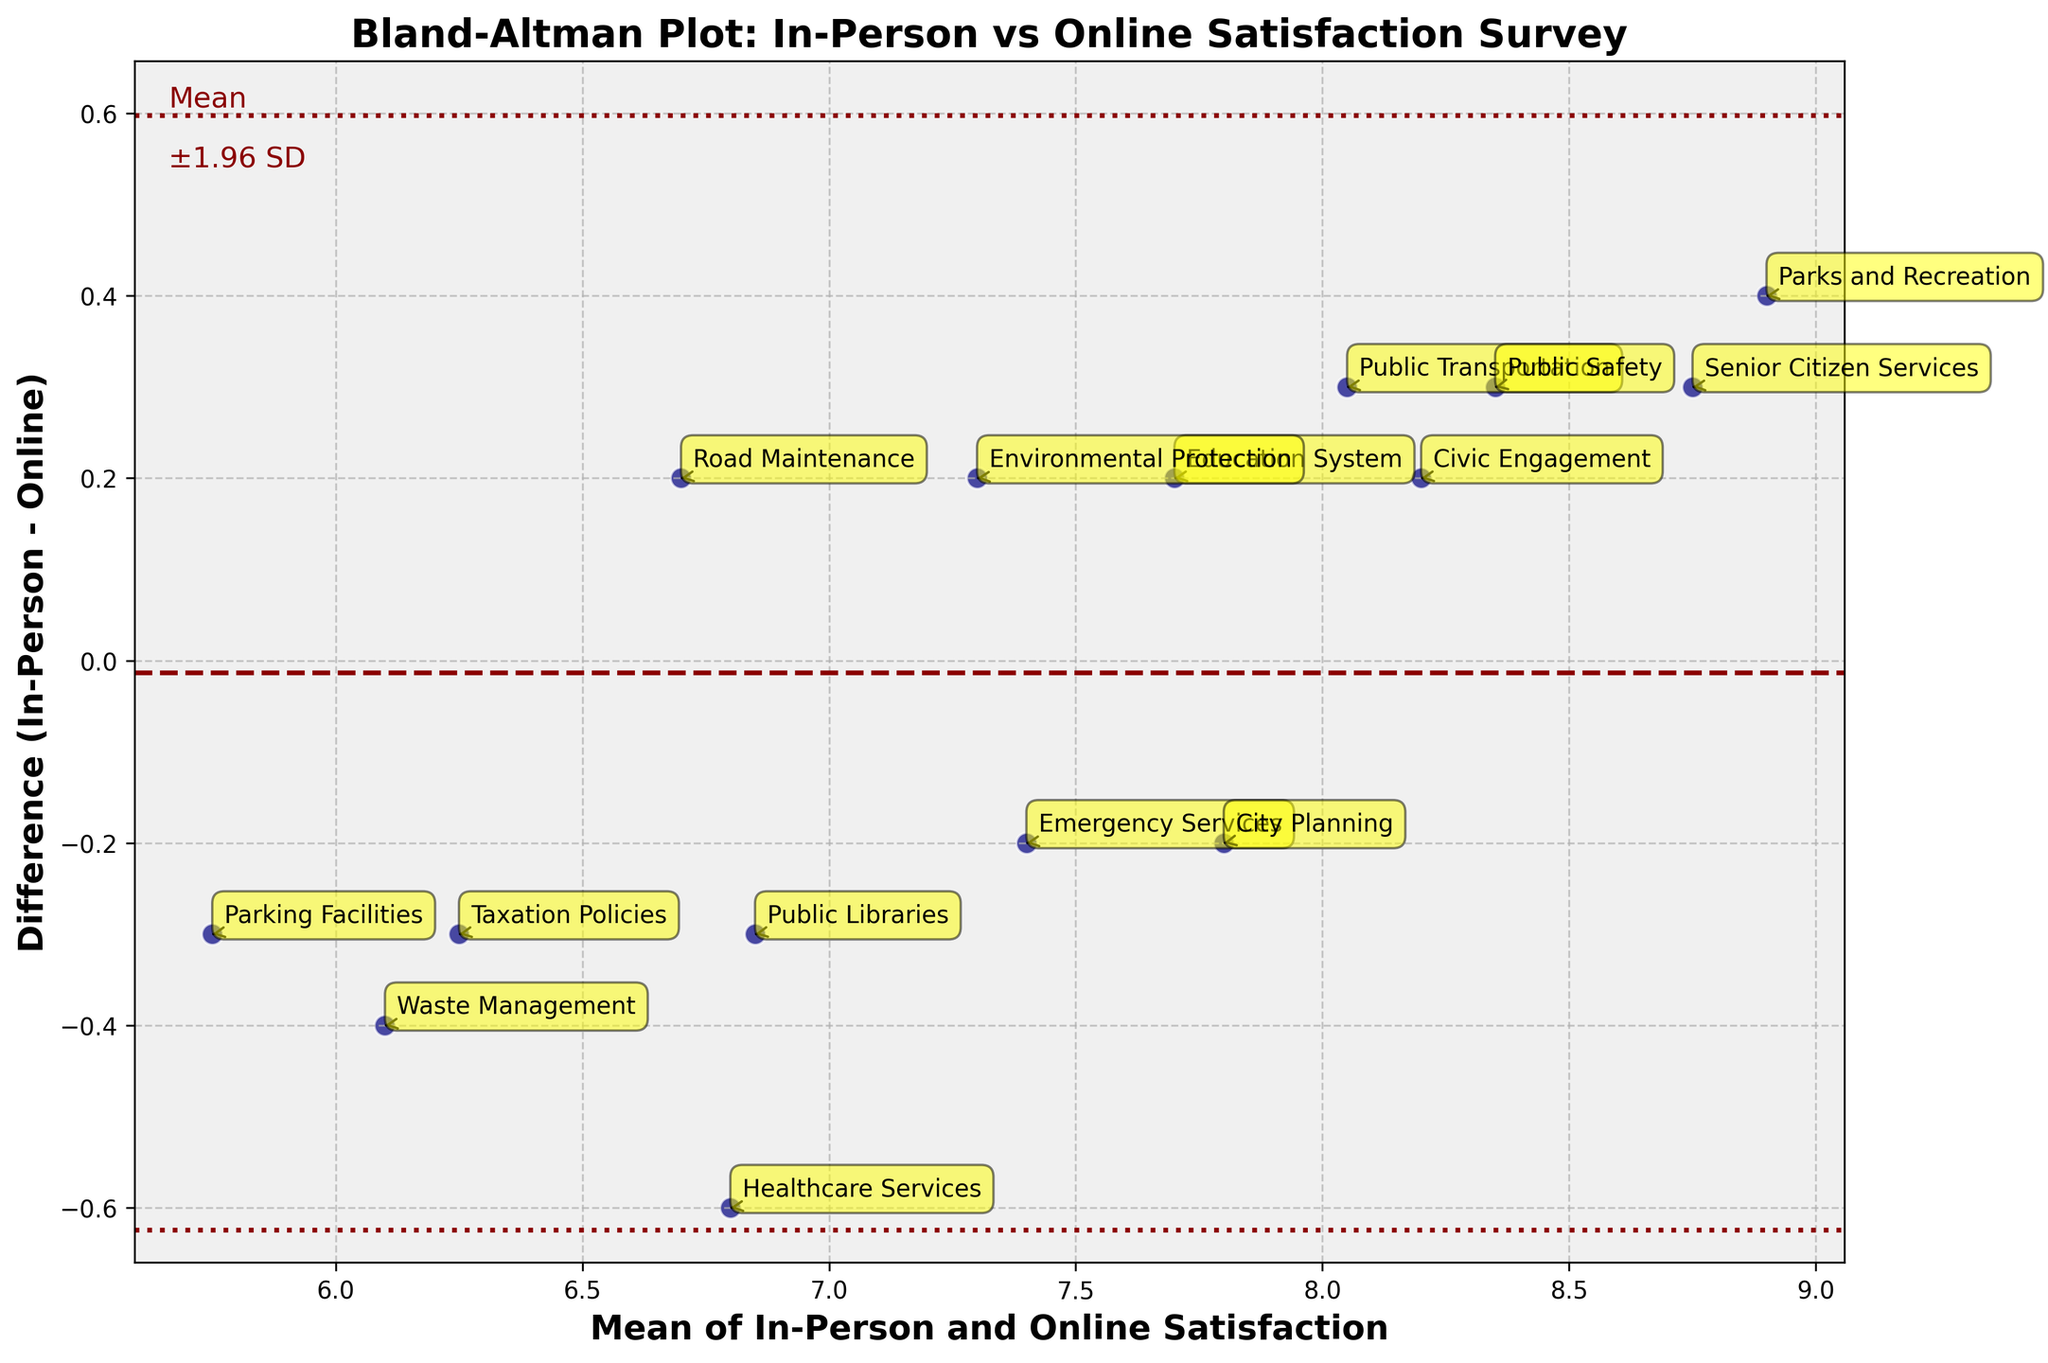How many data points are shown in the plot? To determine the number of data points, observe the number of scatter points present on the plot. Count each point representing a different category.
Answer: 15 What is the title of the plot? Identify the text at the top center of the plot, serving as a descriptor for the visualized data.
Answer: Bland-Altman Plot: In-Person vs Online Satisfaction Survey What do the lines labeled "±1.96 SD" represent? The lines marked as "±1.96 SD" refer to the limits of agreement, indicating where the differences between in-person and online satisfaction results fall within 1.96 standard deviations from the mean difference. These lines help assess the level of agreement.
Answer: Limits of agreement What is the mean difference between the in-person and online surveys? Locate the line that represents the mean difference on the plot. It’s the horizontal line positioned centrally among the data points, annotated as "Mean". Follow the position of this line on the y-axis.
Answer: Approximately 0 Which category shows the largest positive difference between in-person and online satisfaction? Find the data point that is highest above the mean difference line (the line representing y = 0). Check the annotated category for this point.
Answer: Public Safety What is the x-axis label? Look below the horizontal axis to identify the text that describes what this axis represents.
Answer: Mean of In-Person and Online Satisfaction Which category has a mean satisfaction score closest to 7.0? Compare the x-values of all data points to find the one nearest to 7.0. Then, locate the category annotation corresponding to that point.
Answer: Healthcare Services Are the satisfaction ratings more consistent at higher or lower satisfaction levels? Examine the scatter points' spread along the mean satisfaction (x-axis). Determine if points are more concentrated (show less variability) towards the higher or lower ends. Consistency is indicated by closer grouping of points.
Answer: Higher satisfaction levels Does any category fall outside the limit of agreement lines? Look at the scatter points and determine if any of them fall outside the horizontal lines marked as "±1.96 SD".
Answer: No Is there an overall trend of in-person satisfaction being higher or lower than online satisfaction? Assess whether most scatter points lie above or below the mean difference line (y = 0). If more points are above, in-person satisfaction tends to be higher, and vice versa.
Answer: Slightly higher 